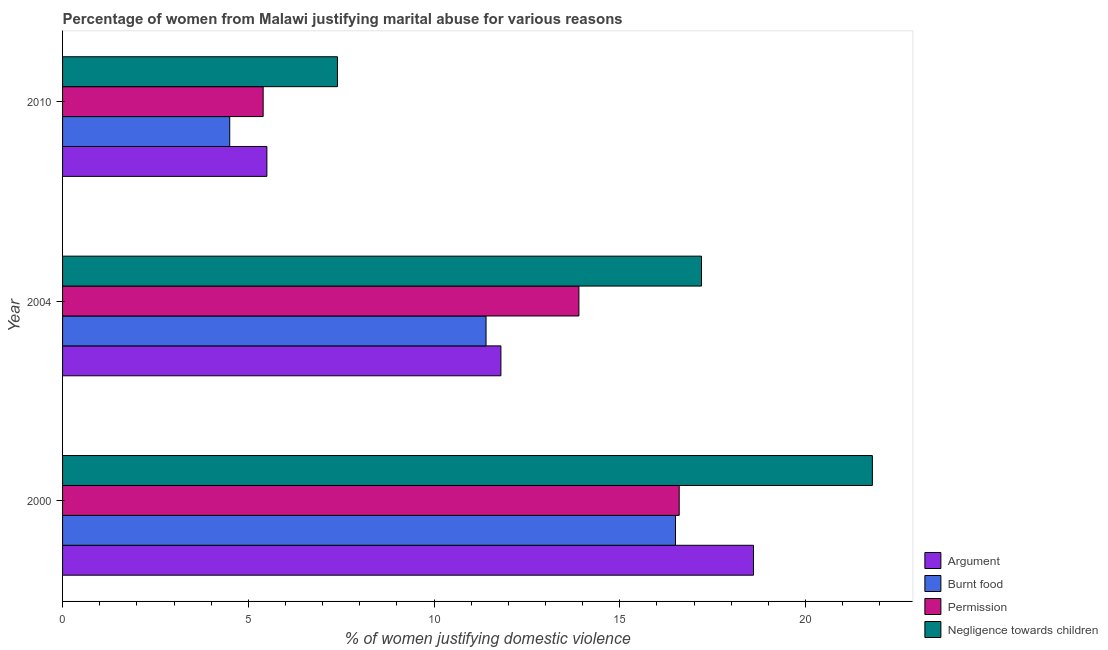How many groups of bars are there?
Your response must be concise. 3. Are the number of bars on each tick of the Y-axis equal?
Your response must be concise. Yes. How many bars are there on the 1st tick from the top?
Provide a succinct answer. 4. In how many cases, is the number of bars for a given year not equal to the number of legend labels?
Your response must be concise. 0. Across all years, what is the maximum percentage of women justifying abuse for showing negligence towards children?
Give a very brief answer. 21.8. Across all years, what is the minimum percentage of women justifying abuse for going without permission?
Your response must be concise. 5.4. In which year was the percentage of women justifying abuse for burning food maximum?
Offer a very short reply. 2000. What is the total percentage of women justifying abuse for showing negligence towards children in the graph?
Your answer should be very brief. 46.4. What is the difference between the percentage of women justifying abuse for burning food in 2004 and that in 2010?
Provide a succinct answer. 6.9. What is the difference between the percentage of women justifying abuse in the case of an argument in 2004 and the percentage of women justifying abuse for going without permission in 2000?
Provide a succinct answer. -4.8. What is the average percentage of women justifying abuse for showing negligence towards children per year?
Make the answer very short. 15.47. In the year 2000, what is the difference between the percentage of women justifying abuse for going without permission and percentage of women justifying abuse in the case of an argument?
Keep it short and to the point. -2. What is the ratio of the percentage of women justifying abuse for burning food in 2000 to that in 2004?
Provide a short and direct response. 1.45. Is the percentage of women justifying abuse for going without permission in 2000 less than that in 2010?
Offer a terse response. No. In how many years, is the percentage of women justifying abuse for going without permission greater than the average percentage of women justifying abuse for going without permission taken over all years?
Your answer should be compact. 2. Is the sum of the percentage of women justifying abuse for burning food in 2000 and 2004 greater than the maximum percentage of women justifying abuse for showing negligence towards children across all years?
Provide a short and direct response. Yes. Is it the case that in every year, the sum of the percentage of women justifying abuse for showing negligence towards children and percentage of women justifying abuse in the case of an argument is greater than the sum of percentage of women justifying abuse for burning food and percentage of women justifying abuse for going without permission?
Your response must be concise. No. What does the 1st bar from the top in 2004 represents?
Offer a terse response. Negligence towards children. What does the 1st bar from the bottom in 2000 represents?
Ensure brevity in your answer.  Argument. Is it the case that in every year, the sum of the percentage of women justifying abuse in the case of an argument and percentage of women justifying abuse for burning food is greater than the percentage of women justifying abuse for going without permission?
Your answer should be compact. Yes. How many bars are there?
Offer a terse response. 12. Are all the bars in the graph horizontal?
Keep it short and to the point. Yes. How many years are there in the graph?
Your answer should be very brief. 3. Are the values on the major ticks of X-axis written in scientific E-notation?
Provide a short and direct response. No. How are the legend labels stacked?
Give a very brief answer. Vertical. What is the title of the graph?
Offer a terse response. Percentage of women from Malawi justifying marital abuse for various reasons. What is the label or title of the X-axis?
Your answer should be very brief. % of women justifying domestic violence. What is the label or title of the Y-axis?
Provide a short and direct response. Year. What is the % of women justifying domestic violence in Argument in 2000?
Your answer should be very brief. 18.6. What is the % of women justifying domestic violence in Burnt food in 2000?
Offer a terse response. 16.5. What is the % of women justifying domestic violence in Negligence towards children in 2000?
Your answer should be very brief. 21.8. What is the % of women justifying domestic violence of Burnt food in 2004?
Your answer should be compact. 11.4. What is the % of women justifying domestic violence of Negligence towards children in 2004?
Offer a terse response. 17.2. What is the % of women justifying domestic violence in Burnt food in 2010?
Your response must be concise. 4.5. Across all years, what is the maximum % of women justifying domestic violence in Burnt food?
Your answer should be very brief. 16.5. Across all years, what is the maximum % of women justifying domestic violence of Permission?
Ensure brevity in your answer.  16.6. Across all years, what is the maximum % of women justifying domestic violence of Negligence towards children?
Provide a succinct answer. 21.8. Across all years, what is the minimum % of women justifying domestic violence in Argument?
Your answer should be very brief. 5.5. Across all years, what is the minimum % of women justifying domestic violence of Negligence towards children?
Your answer should be compact. 7.4. What is the total % of women justifying domestic violence in Argument in the graph?
Your answer should be compact. 35.9. What is the total % of women justifying domestic violence in Burnt food in the graph?
Make the answer very short. 32.4. What is the total % of women justifying domestic violence in Permission in the graph?
Offer a terse response. 35.9. What is the total % of women justifying domestic violence in Negligence towards children in the graph?
Provide a short and direct response. 46.4. What is the difference between the % of women justifying domestic violence in Burnt food in 2000 and that in 2004?
Ensure brevity in your answer.  5.1. What is the difference between the % of women justifying domestic violence of Burnt food in 2000 and that in 2010?
Offer a very short reply. 12. What is the difference between the % of women justifying domestic violence in Argument in 2000 and the % of women justifying domestic violence in Burnt food in 2004?
Make the answer very short. 7.2. What is the difference between the % of women justifying domestic violence of Argument in 2000 and the % of women justifying domestic violence of Permission in 2004?
Ensure brevity in your answer.  4.7. What is the difference between the % of women justifying domestic violence in Burnt food in 2000 and the % of women justifying domestic violence in Permission in 2004?
Your answer should be very brief. 2.6. What is the difference between the % of women justifying domestic violence in Argument in 2000 and the % of women justifying domestic violence in Burnt food in 2010?
Your answer should be very brief. 14.1. What is the difference between the % of women justifying domestic violence in Argument in 2000 and the % of women justifying domestic violence in Negligence towards children in 2010?
Offer a very short reply. 11.2. What is the difference between the % of women justifying domestic violence of Burnt food in 2000 and the % of women justifying domestic violence of Negligence towards children in 2010?
Provide a short and direct response. 9.1. What is the difference between the % of women justifying domestic violence in Permission in 2000 and the % of women justifying domestic violence in Negligence towards children in 2010?
Your response must be concise. 9.2. What is the difference between the % of women justifying domestic violence in Argument in 2004 and the % of women justifying domestic violence in Permission in 2010?
Your response must be concise. 6.4. What is the difference between the % of women justifying domestic violence of Argument in 2004 and the % of women justifying domestic violence of Negligence towards children in 2010?
Offer a very short reply. 4.4. What is the difference between the % of women justifying domestic violence in Burnt food in 2004 and the % of women justifying domestic violence in Permission in 2010?
Keep it short and to the point. 6. What is the difference between the % of women justifying domestic violence in Burnt food in 2004 and the % of women justifying domestic violence in Negligence towards children in 2010?
Offer a terse response. 4. What is the difference between the % of women justifying domestic violence of Permission in 2004 and the % of women justifying domestic violence of Negligence towards children in 2010?
Offer a very short reply. 6.5. What is the average % of women justifying domestic violence in Argument per year?
Your response must be concise. 11.97. What is the average % of women justifying domestic violence of Burnt food per year?
Offer a very short reply. 10.8. What is the average % of women justifying domestic violence in Permission per year?
Keep it short and to the point. 11.97. What is the average % of women justifying domestic violence of Negligence towards children per year?
Provide a short and direct response. 15.47. In the year 2000, what is the difference between the % of women justifying domestic violence of Argument and % of women justifying domestic violence of Burnt food?
Your answer should be very brief. 2.1. In the year 2000, what is the difference between the % of women justifying domestic violence of Argument and % of women justifying domestic violence of Permission?
Your answer should be compact. 2. In the year 2000, what is the difference between the % of women justifying domestic violence in Argument and % of women justifying domestic violence in Negligence towards children?
Your answer should be very brief. -3.2. In the year 2000, what is the difference between the % of women justifying domestic violence of Burnt food and % of women justifying domestic violence of Negligence towards children?
Give a very brief answer. -5.3. In the year 2004, what is the difference between the % of women justifying domestic violence in Argument and % of women justifying domestic violence in Permission?
Your answer should be compact. -2.1. In the year 2004, what is the difference between the % of women justifying domestic violence of Burnt food and % of women justifying domestic violence of Negligence towards children?
Your response must be concise. -5.8. In the year 2004, what is the difference between the % of women justifying domestic violence in Permission and % of women justifying domestic violence in Negligence towards children?
Offer a terse response. -3.3. In the year 2010, what is the difference between the % of women justifying domestic violence of Argument and % of women justifying domestic violence of Permission?
Provide a short and direct response. 0.1. In the year 2010, what is the difference between the % of women justifying domestic violence in Argument and % of women justifying domestic violence in Negligence towards children?
Your answer should be very brief. -1.9. In the year 2010, what is the difference between the % of women justifying domestic violence in Burnt food and % of women justifying domestic violence in Permission?
Offer a terse response. -0.9. In the year 2010, what is the difference between the % of women justifying domestic violence in Permission and % of women justifying domestic violence in Negligence towards children?
Your answer should be compact. -2. What is the ratio of the % of women justifying domestic violence in Argument in 2000 to that in 2004?
Keep it short and to the point. 1.58. What is the ratio of the % of women justifying domestic violence in Burnt food in 2000 to that in 2004?
Make the answer very short. 1.45. What is the ratio of the % of women justifying domestic violence of Permission in 2000 to that in 2004?
Make the answer very short. 1.19. What is the ratio of the % of women justifying domestic violence of Negligence towards children in 2000 to that in 2004?
Your answer should be very brief. 1.27. What is the ratio of the % of women justifying domestic violence of Argument in 2000 to that in 2010?
Your answer should be compact. 3.38. What is the ratio of the % of women justifying domestic violence in Burnt food in 2000 to that in 2010?
Make the answer very short. 3.67. What is the ratio of the % of women justifying domestic violence of Permission in 2000 to that in 2010?
Make the answer very short. 3.07. What is the ratio of the % of women justifying domestic violence of Negligence towards children in 2000 to that in 2010?
Provide a succinct answer. 2.95. What is the ratio of the % of women justifying domestic violence of Argument in 2004 to that in 2010?
Offer a very short reply. 2.15. What is the ratio of the % of women justifying domestic violence in Burnt food in 2004 to that in 2010?
Keep it short and to the point. 2.53. What is the ratio of the % of women justifying domestic violence of Permission in 2004 to that in 2010?
Provide a short and direct response. 2.57. What is the ratio of the % of women justifying domestic violence of Negligence towards children in 2004 to that in 2010?
Give a very brief answer. 2.32. What is the difference between the highest and the second highest % of women justifying domestic violence in Argument?
Your answer should be very brief. 6.8. What is the difference between the highest and the second highest % of women justifying domestic violence of Permission?
Offer a very short reply. 2.7. What is the difference between the highest and the lowest % of women justifying domestic violence in Burnt food?
Your response must be concise. 12. What is the difference between the highest and the lowest % of women justifying domestic violence of Permission?
Provide a short and direct response. 11.2. 